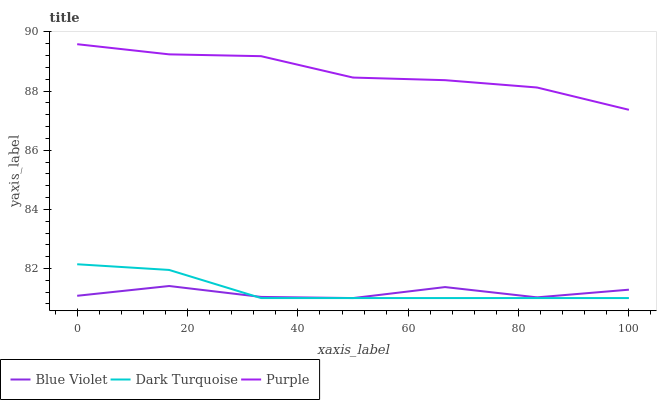Does Blue Violet have the minimum area under the curve?
Answer yes or no. Yes. Does Purple have the maximum area under the curve?
Answer yes or no. Yes. Does Dark Turquoise have the minimum area under the curve?
Answer yes or no. No. Does Dark Turquoise have the maximum area under the curve?
Answer yes or no. No. Is Dark Turquoise the smoothest?
Answer yes or no. Yes. Is Blue Violet the roughest?
Answer yes or no. Yes. Is Blue Violet the smoothest?
Answer yes or no. No. Is Dark Turquoise the roughest?
Answer yes or no. No. Does Dark Turquoise have the lowest value?
Answer yes or no. Yes. Does Purple have the highest value?
Answer yes or no. Yes. Does Dark Turquoise have the highest value?
Answer yes or no. No. Is Dark Turquoise less than Purple?
Answer yes or no. Yes. Is Purple greater than Dark Turquoise?
Answer yes or no. Yes. Does Dark Turquoise intersect Blue Violet?
Answer yes or no. Yes. Is Dark Turquoise less than Blue Violet?
Answer yes or no. No. Is Dark Turquoise greater than Blue Violet?
Answer yes or no. No. Does Dark Turquoise intersect Purple?
Answer yes or no. No. 